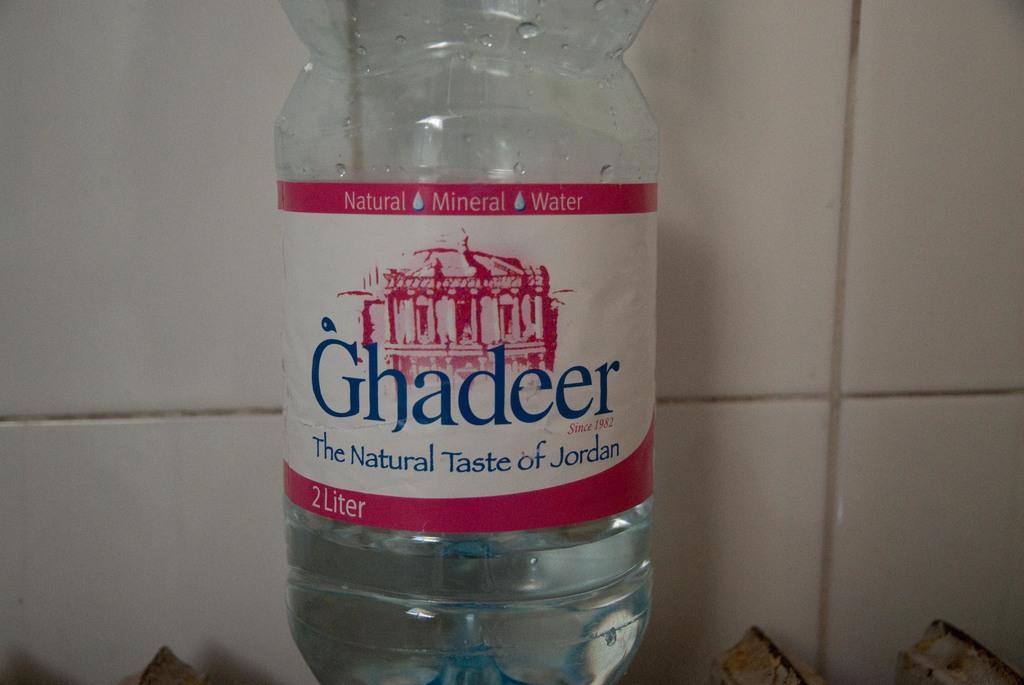What is the brand on the water bottle?
Give a very brief answer. Ghadeer. What country is the water from?
Provide a short and direct response. Jordan. 